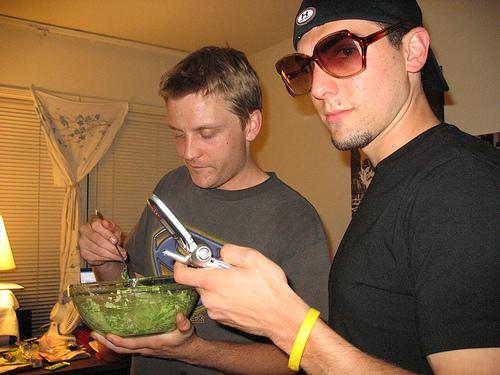Question: how many people are in the picture?
Choices:
A. 1.
B. 3.
C. 2.
D. 4.
Answer with the letter. Answer: C Question: where is the cell phone?
Choices:
A. In the man's pocket.
B. In the man's briefcase.
C. On the table.
D. In the man's hand.
Answer with the letter. Answer: D Question: what is hanging over the window?
Choices:
A. A towel.
B. A rug.
C. A person.
D. A dog.
Answer with the letter. Answer: A Question: who is looking at the camera?
Choices:
A. The man on the right.
B. The woman.
C. The policeman.
D. The fireman.
Answer with the letter. Answer: A Question: what is on the man's head?
Choices:
A. A cat.
B. A hamster.
C. A bald spot.
D. A hat.
Answer with the letter. Answer: D 